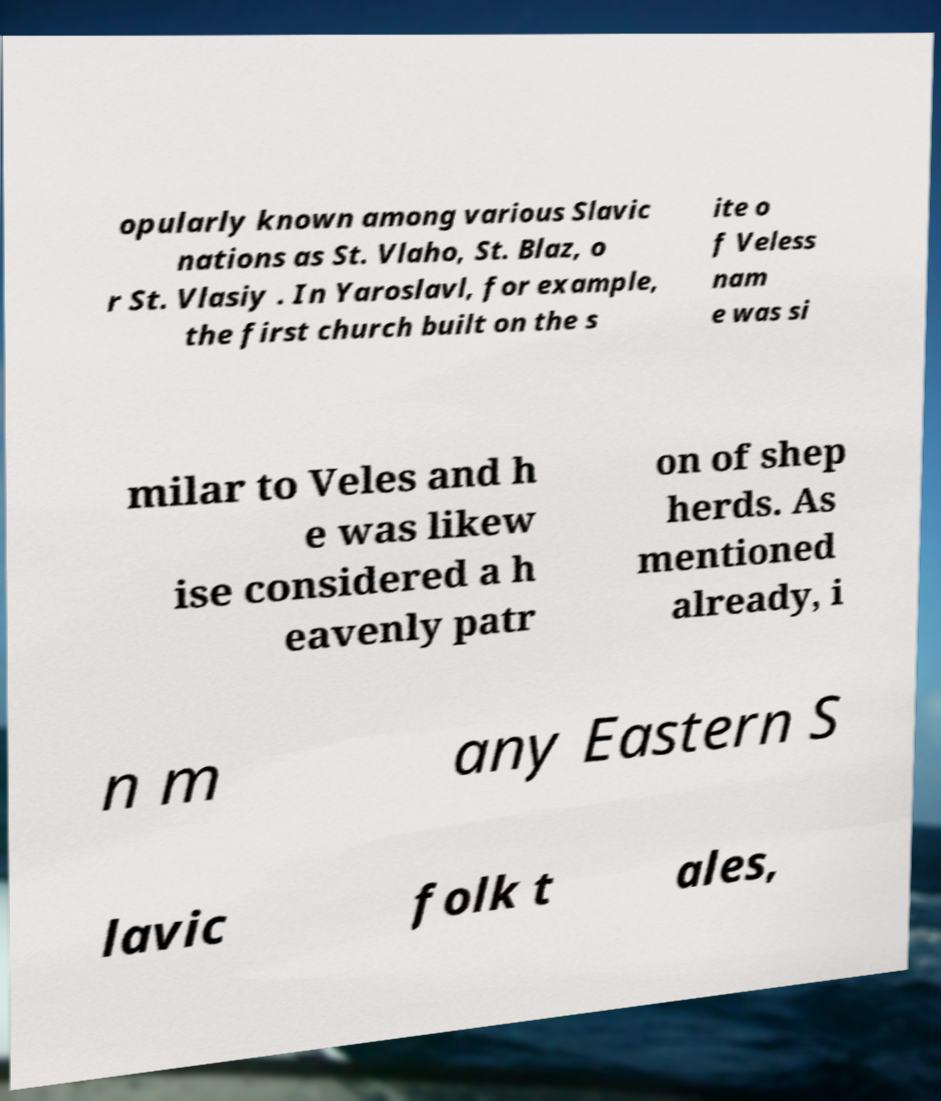What messages or text are displayed in this image? I need them in a readable, typed format. opularly known among various Slavic nations as St. Vlaho, St. Blaz, o r St. Vlasiy . In Yaroslavl, for example, the first church built on the s ite o f Veless nam e was si milar to Veles and h e was likew ise considered a h eavenly patr on of shep herds. As mentioned already, i n m any Eastern S lavic folk t ales, 